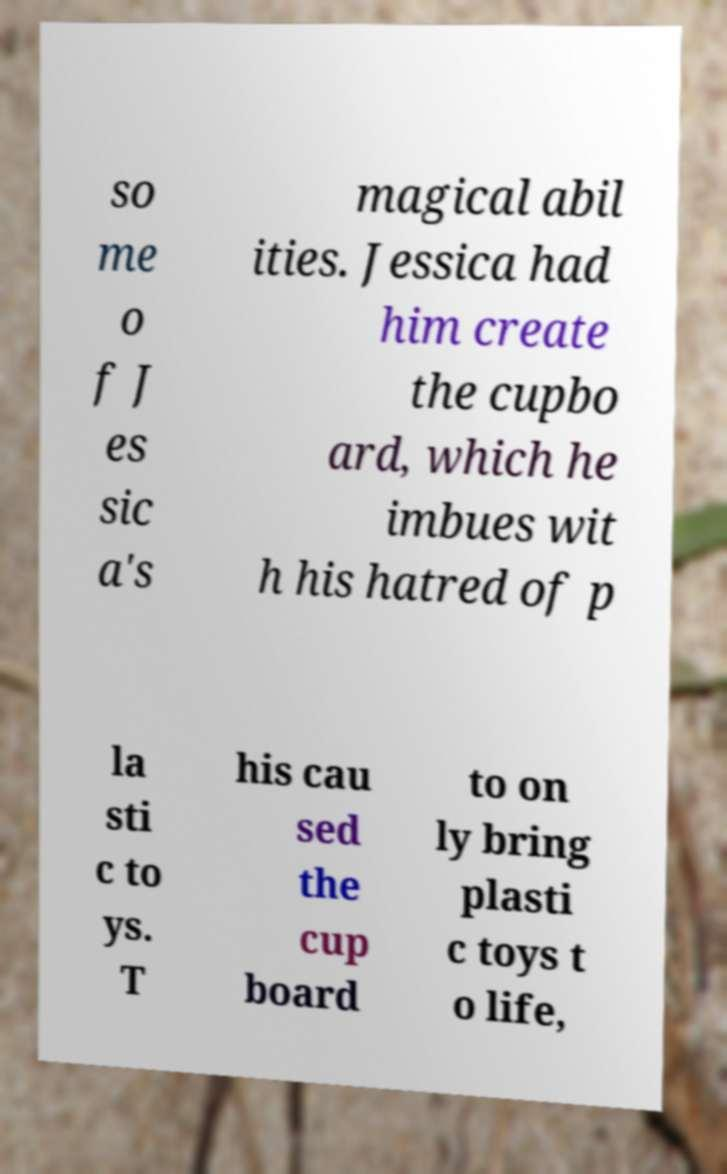Could you assist in decoding the text presented in this image and type it out clearly? so me o f J es sic a's magical abil ities. Jessica had him create the cupbo ard, which he imbues wit h his hatred of p la sti c to ys. T his cau sed the cup board to on ly bring plasti c toys t o life, 